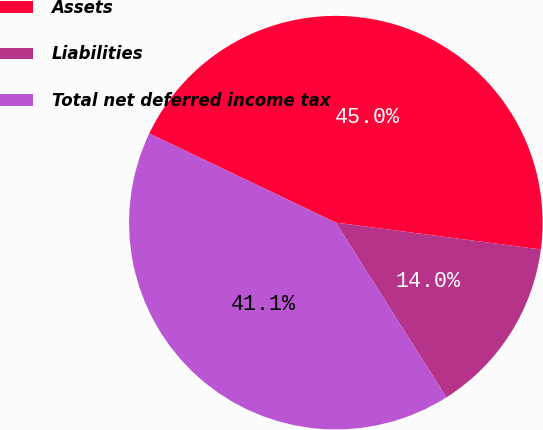Convert chart. <chart><loc_0><loc_0><loc_500><loc_500><pie_chart><fcel>Assets<fcel>Liabilities<fcel>Total net deferred income tax<nl><fcel>44.97%<fcel>13.95%<fcel>41.07%<nl></chart> 